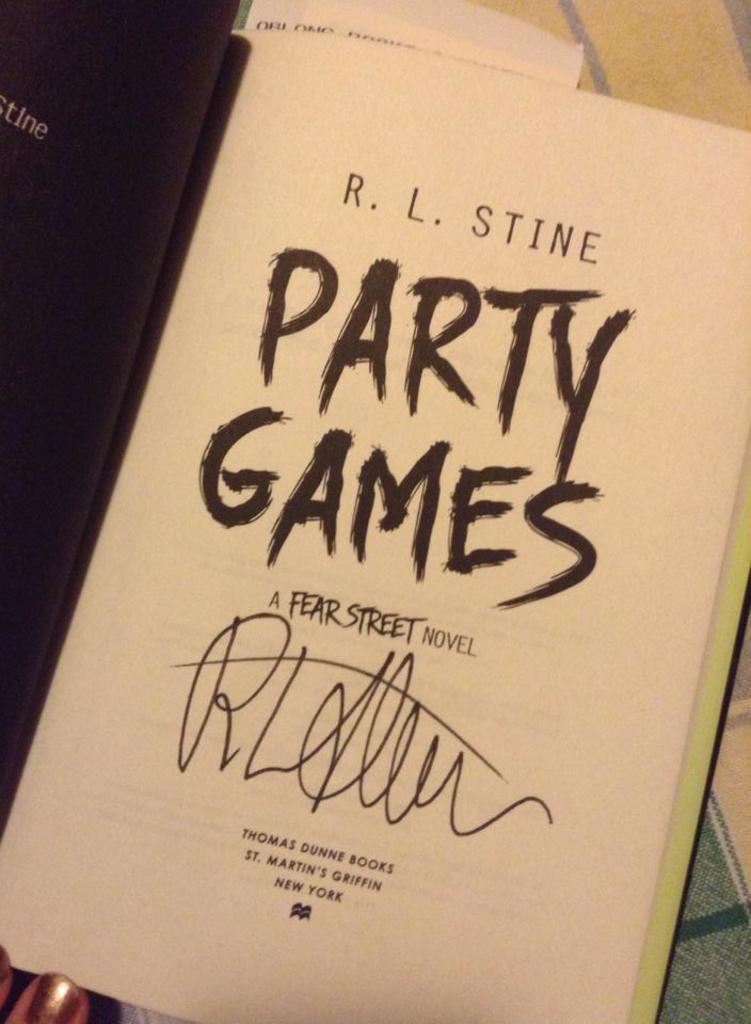<image>
Give a short and clear explanation of the subsequent image. Open book for Party Games by R.L. Stine. 